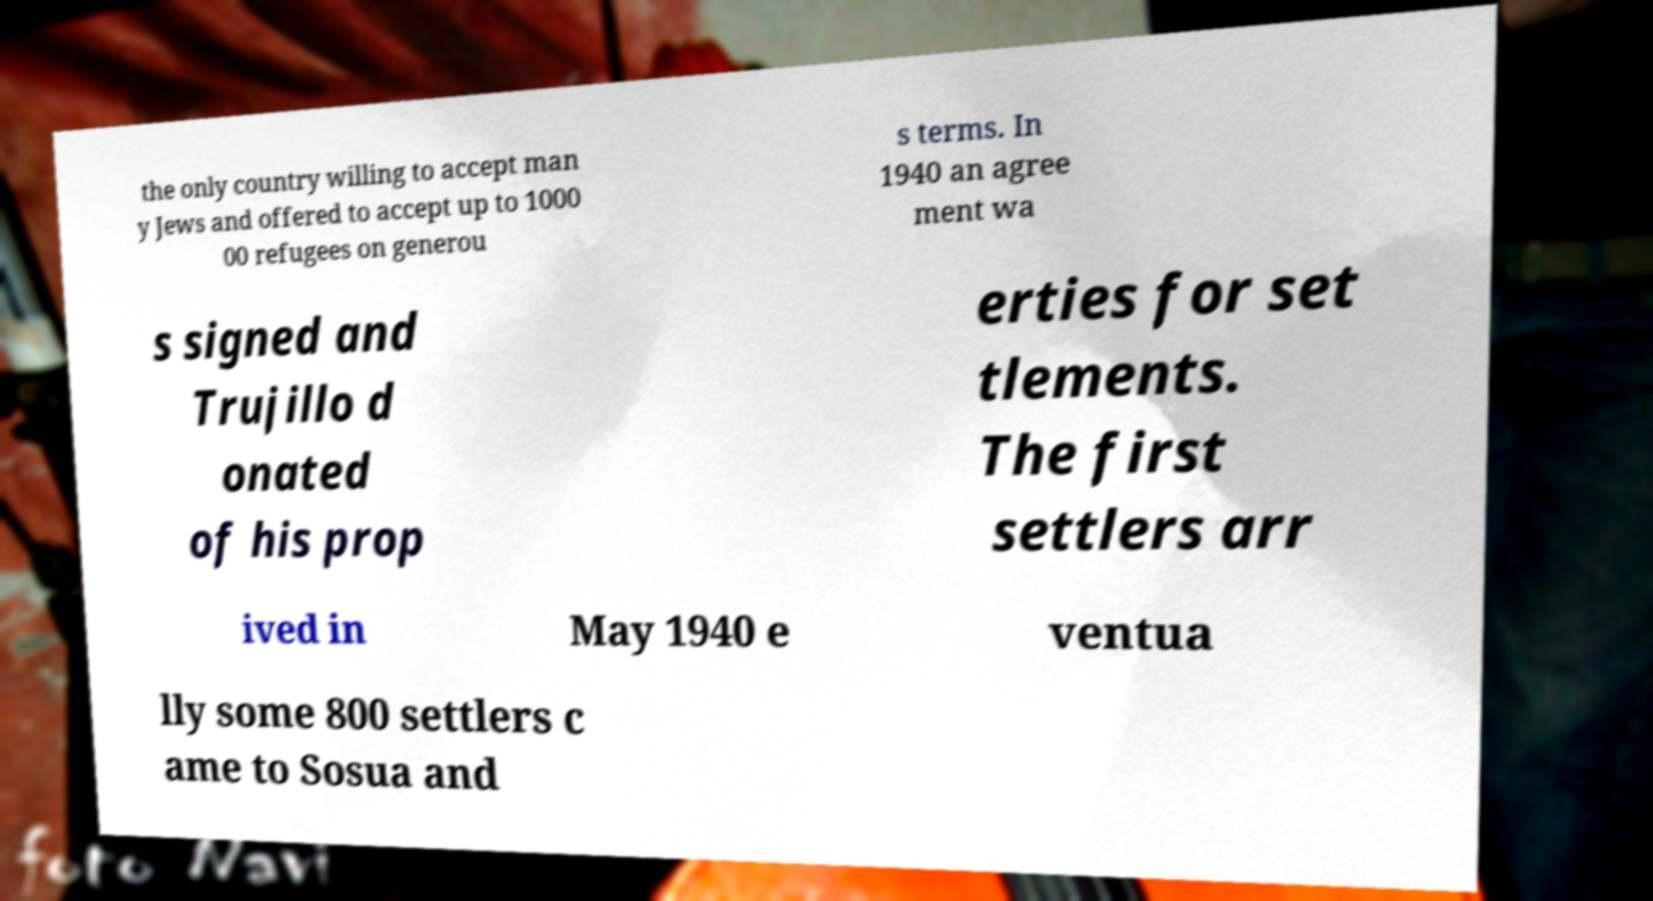Please read and relay the text visible in this image. What does it say? the only country willing to accept man y Jews and offered to accept up to 1000 00 refugees on generou s terms. In 1940 an agree ment wa s signed and Trujillo d onated of his prop erties for set tlements. The first settlers arr ived in May 1940 e ventua lly some 800 settlers c ame to Sosua and 